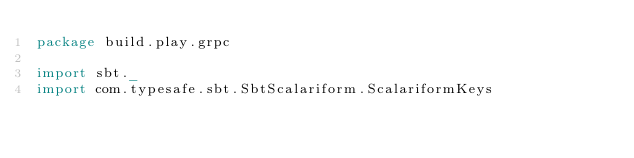<code> <loc_0><loc_0><loc_500><loc_500><_Scala_>package build.play.grpc

import sbt._
import com.typesafe.sbt.SbtScalariform.ScalariformKeys
</code> 